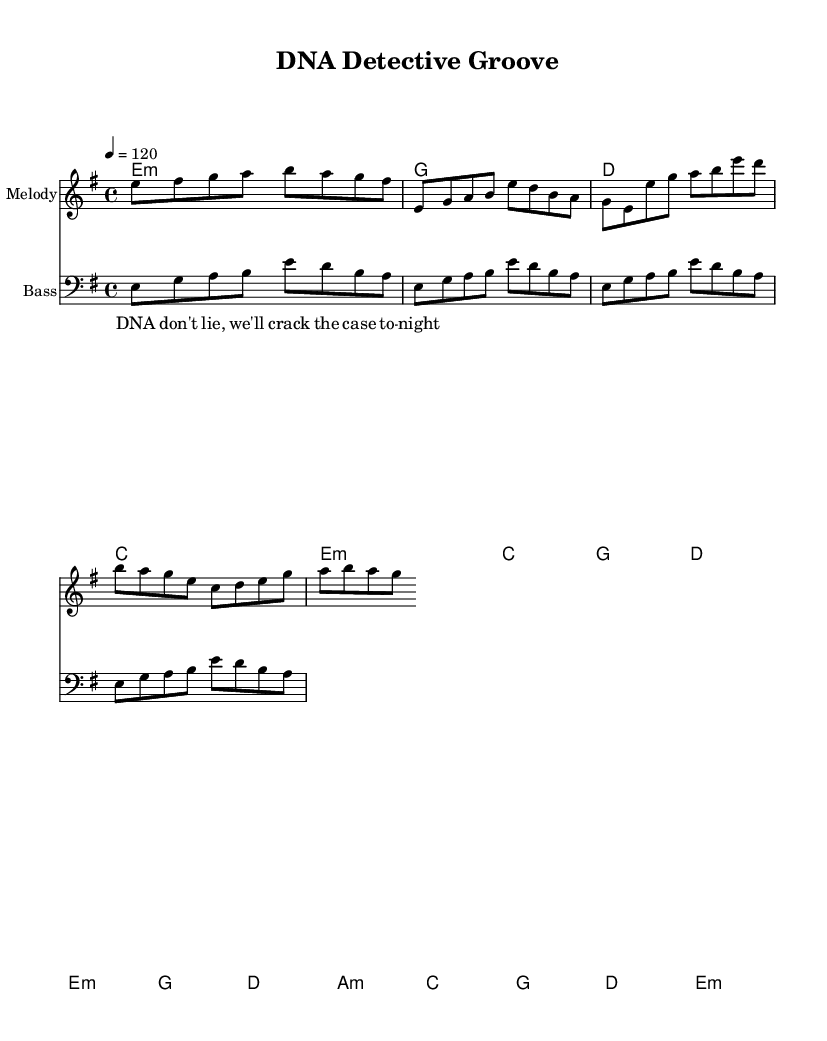What is the key signature of this music? The key signature is indicated at the beginning of the music. In this case, it shows E minor, which has one sharp (F#).
Answer: E minor What is the time signature of this music? The time signature is found at the beginning of the music. Here, it is 4/4, meaning there are four beats in each measure, and the quarter note gets one beat.
Answer: 4/4 What is the tempo marking of the piece? The tempo marking is indicated with a metronome marking at the start of the music. This piece has a tempo of 120 beats per minute.
Answer: 120 How many measures are in the melody section? To find the number of measures, you count the distinct measures where the melody is played. In this score, the melody sections (intro, verse, chorus, bridge) consist of 7 measures in total.
Answer: 7 What is the name of the piece? The title of the music is provided at the top of the sheet music in the header section. It is titled "DNA Detective Groove."
Answer: DNA Detective Groove What instruments are scored in this music? The instruments being used are indicated at the beginning of each staff. This score has a melody staff and a bass staff, indicating it features a melody instrument and a bass instrument.
Answer: Melody, Bass What genre does this piece belong to? The genre can be inferred from the context and the title, which references high-energy funk antithems, indicating it is a Funk piece.
Answer: Funk 